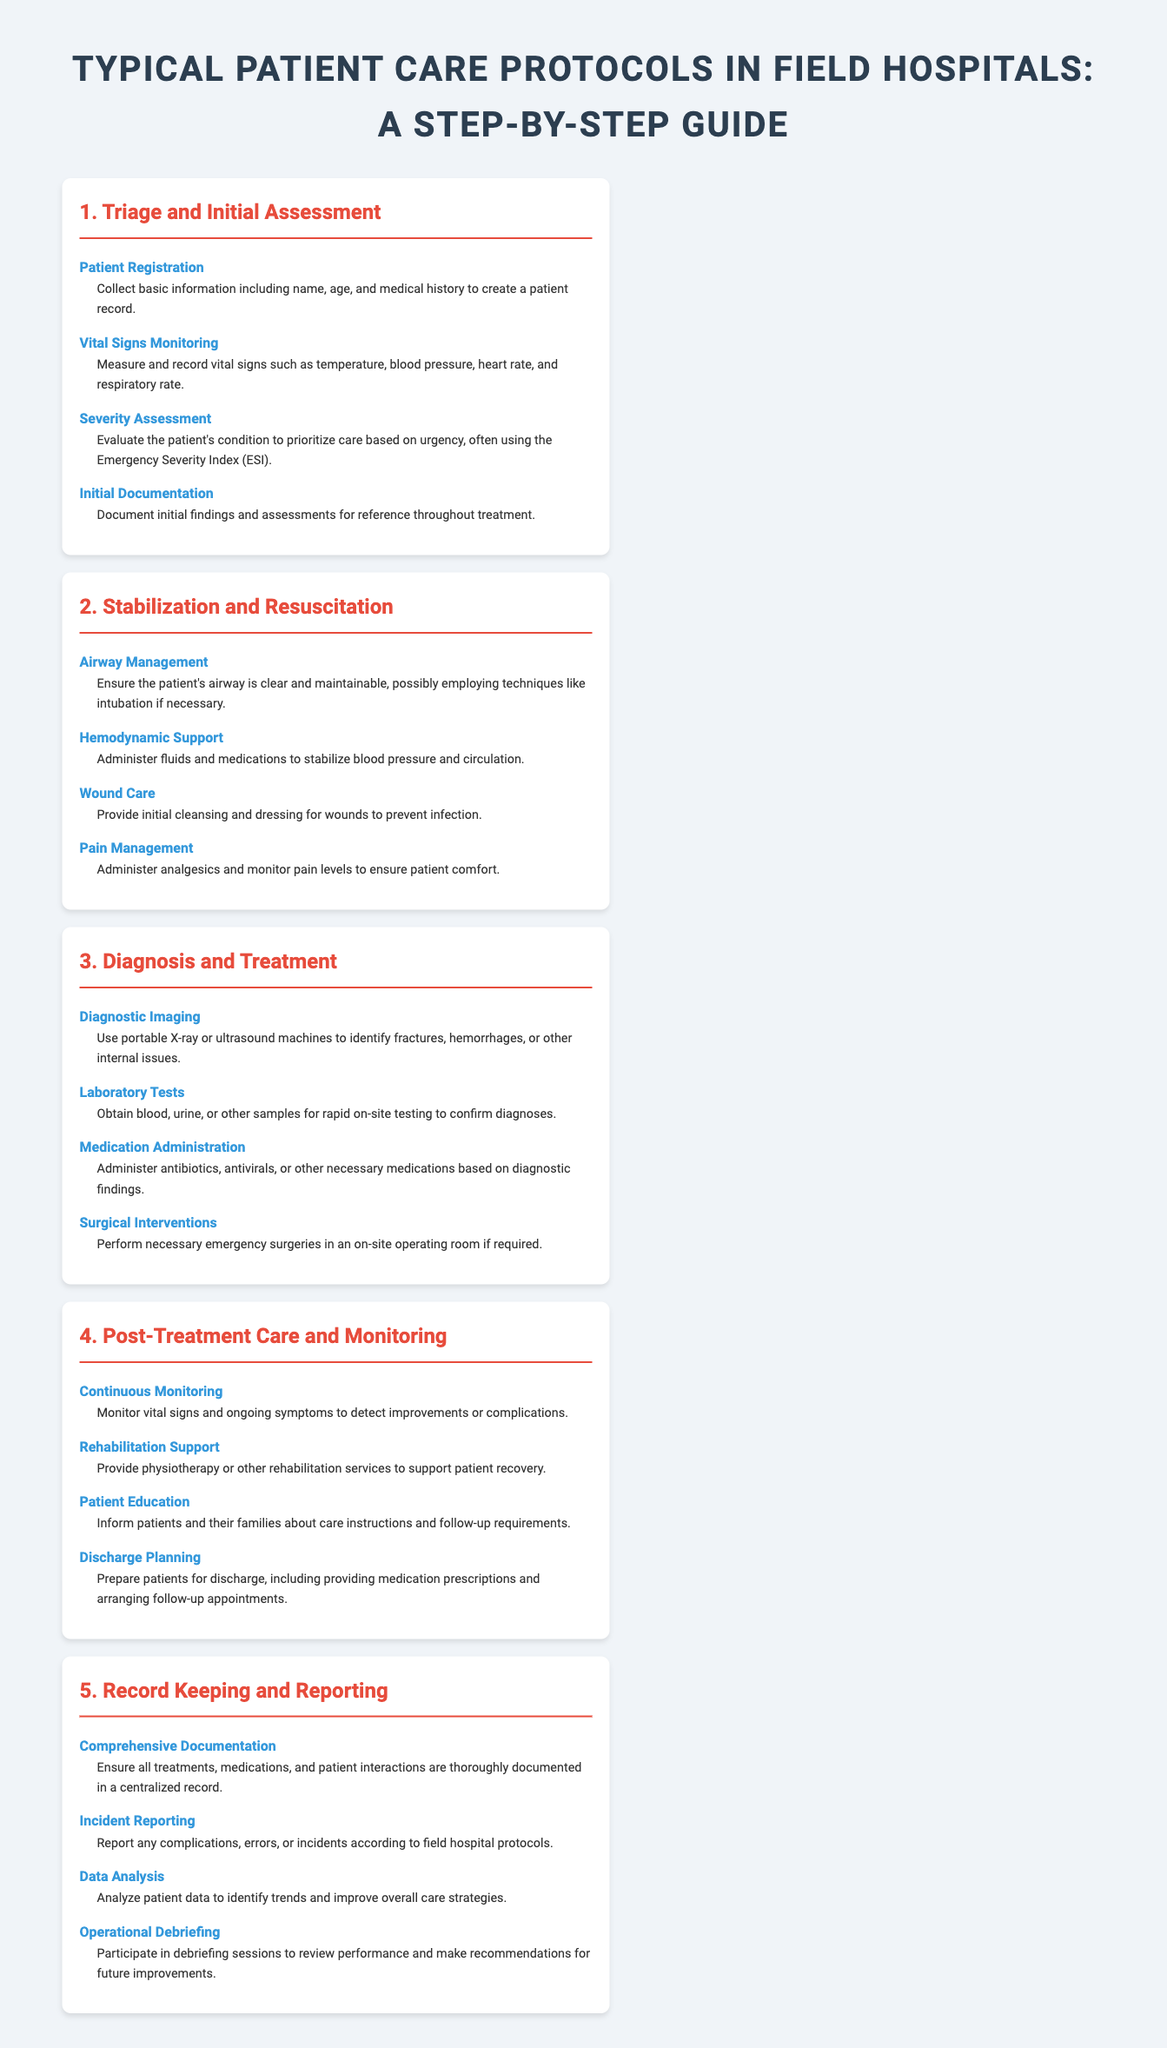What is the first step in patient care protocols? The first step in patient care protocols is Triage and Initial Assessment, which includes patient registration.
Answer: Triage and Initial Assessment What is the main purpose of the Severity Assessment? The purpose of the Severity Assessment is to evaluate the patient's condition to prioritize care based on urgency.
Answer: Prioritize care How many steps are there in the Stabilization and Resuscitation section? The number of steps in the Stabilization and Resuscitation section is four.
Answer: Four What type of imaging is used for diagnosis? The type of imaging used for diagnosis is portable X-ray or ultrasound machines.
Answer: Portable X-ray or ultrasound Which step involves educating patients about care instructions? The step that involves educating patients is Patient Education in the Post-Treatment Care and Monitoring section.
Answer: Patient Education What is documented during the Initial Documentation step? Initial Documentation involves documenting initial findings and assessments for reference throughout treatment.
Answer: Initial findings and assessments Which section encompasses discharge planning? Discharge Planning is included in the Post-Treatment Care and Monitoring section.
Answer: Post-Treatment Care and Monitoring How many total sections are in the document? There are five total sections in the document about patient care protocols.
Answer: Five What is required for Complications reporting? Reporting any complications, errors, or incidents is required according to field hospital protocols.
Answer: Field hospital protocols 